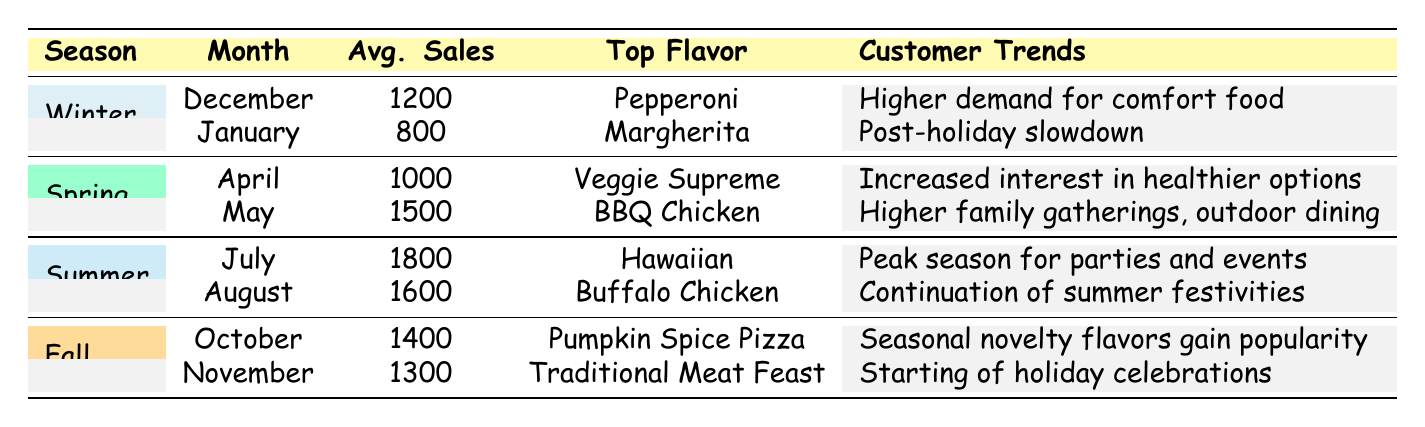What was the top flavor in Summer? According to the table, the top flavor for Summer is listed under both July and August. In July, it is Hawaiian, and in August, it is Buffalo Chicken. Since the question asks for the top flavor generally in Summer, we can refer to the highest sales month, which is July with the Hawaiian flavor leading.
Answer: Hawaiian What is the average number of sales units for Fall? To find the average sales for Fall, we can take the sales units from October (1400) and November (1300), sum them up (1400 + 1300 = 2700), and then divide by the number of months (2). Therefore, the average sales for Fall are 2700 / 2 = 1350.
Answer: 1350 Did sales increase from Winter to Spring? To determine if sales increased from Winter to Spring, we need to look at the average sales from both seasons. The average for Winter is (1200 + 800) / 2 = 1000 and for Spring it is (1000 + 1500) / 2 = 1250. Since 1250 is greater than 1000, we can conclude that sales did increase.
Answer: Yes Which month had the highest average sales units? By examining the table, the month with the highest average sales is July, with 1800 average sales units. It is important to read the sales figures in each season, and July stands out as the peak month.
Answer: July What customer trend was noted for October? The customer trend noted for October is "Seasonal novelty flavors gain popularity," as stated in the table under the Fall season for that month. This indicates specific consumer behavior during that time.
Answer: Seasonal novelty flavors gain popularity What is the total average sales units for all Winter months combined? The average sales units for Winter are December (1200) and January (800). To find the total, we add these figures together: 1200 + 800 = 2000. Thus, the total average sales units for the Winter months combined is 2000.
Answer: 2000 Is BBQ Chicken the only top flavor in Spring? In Spring, there are two months listed: April has Veggie Supreme and May has BBQ Chicken. Since there are different top flavors, BBQ Chicken is not the only one in Spring.
Answer: No Which month had the lowest average sales units? The month with the lowest average sales units is January, with 800 units sold. By looking at the average sales figures across all months, January stands out as the lowest.
Answer: January What was the customer trend in December? The customer trend for December is described as "Higher demand for comfort food," which reflects consumer preferences during the Winter season and the holiday time.
Answer: Higher demand for comfort food 